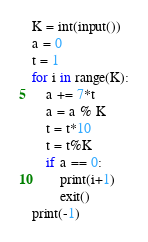<code> <loc_0><loc_0><loc_500><loc_500><_Python_>K = int(input())
a = 0
t = 1
for i in range(K):
    a += 7*t
    a = a % K
    t = t*10
    t = t%K
    if a == 0:
        print(i+1)
        exit()
print(-1)
</code> 